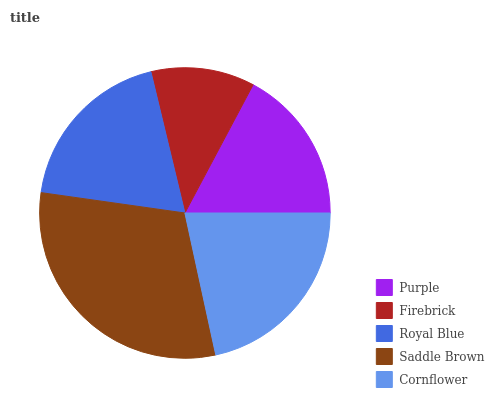Is Firebrick the minimum?
Answer yes or no. Yes. Is Saddle Brown the maximum?
Answer yes or no. Yes. Is Royal Blue the minimum?
Answer yes or no. No. Is Royal Blue the maximum?
Answer yes or no. No. Is Royal Blue greater than Firebrick?
Answer yes or no. Yes. Is Firebrick less than Royal Blue?
Answer yes or no. Yes. Is Firebrick greater than Royal Blue?
Answer yes or no. No. Is Royal Blue less than Firebrick?
Answer yes or no. No. Is Royal Blue the high median?
Answer yes or no. Yes. Is Royal Blue the low median?
Answer yes or no. Yes. Is Purple the high median?
Answer yes or no. No. Is Saddle Brown the low median?
Answer yes or no. No. 